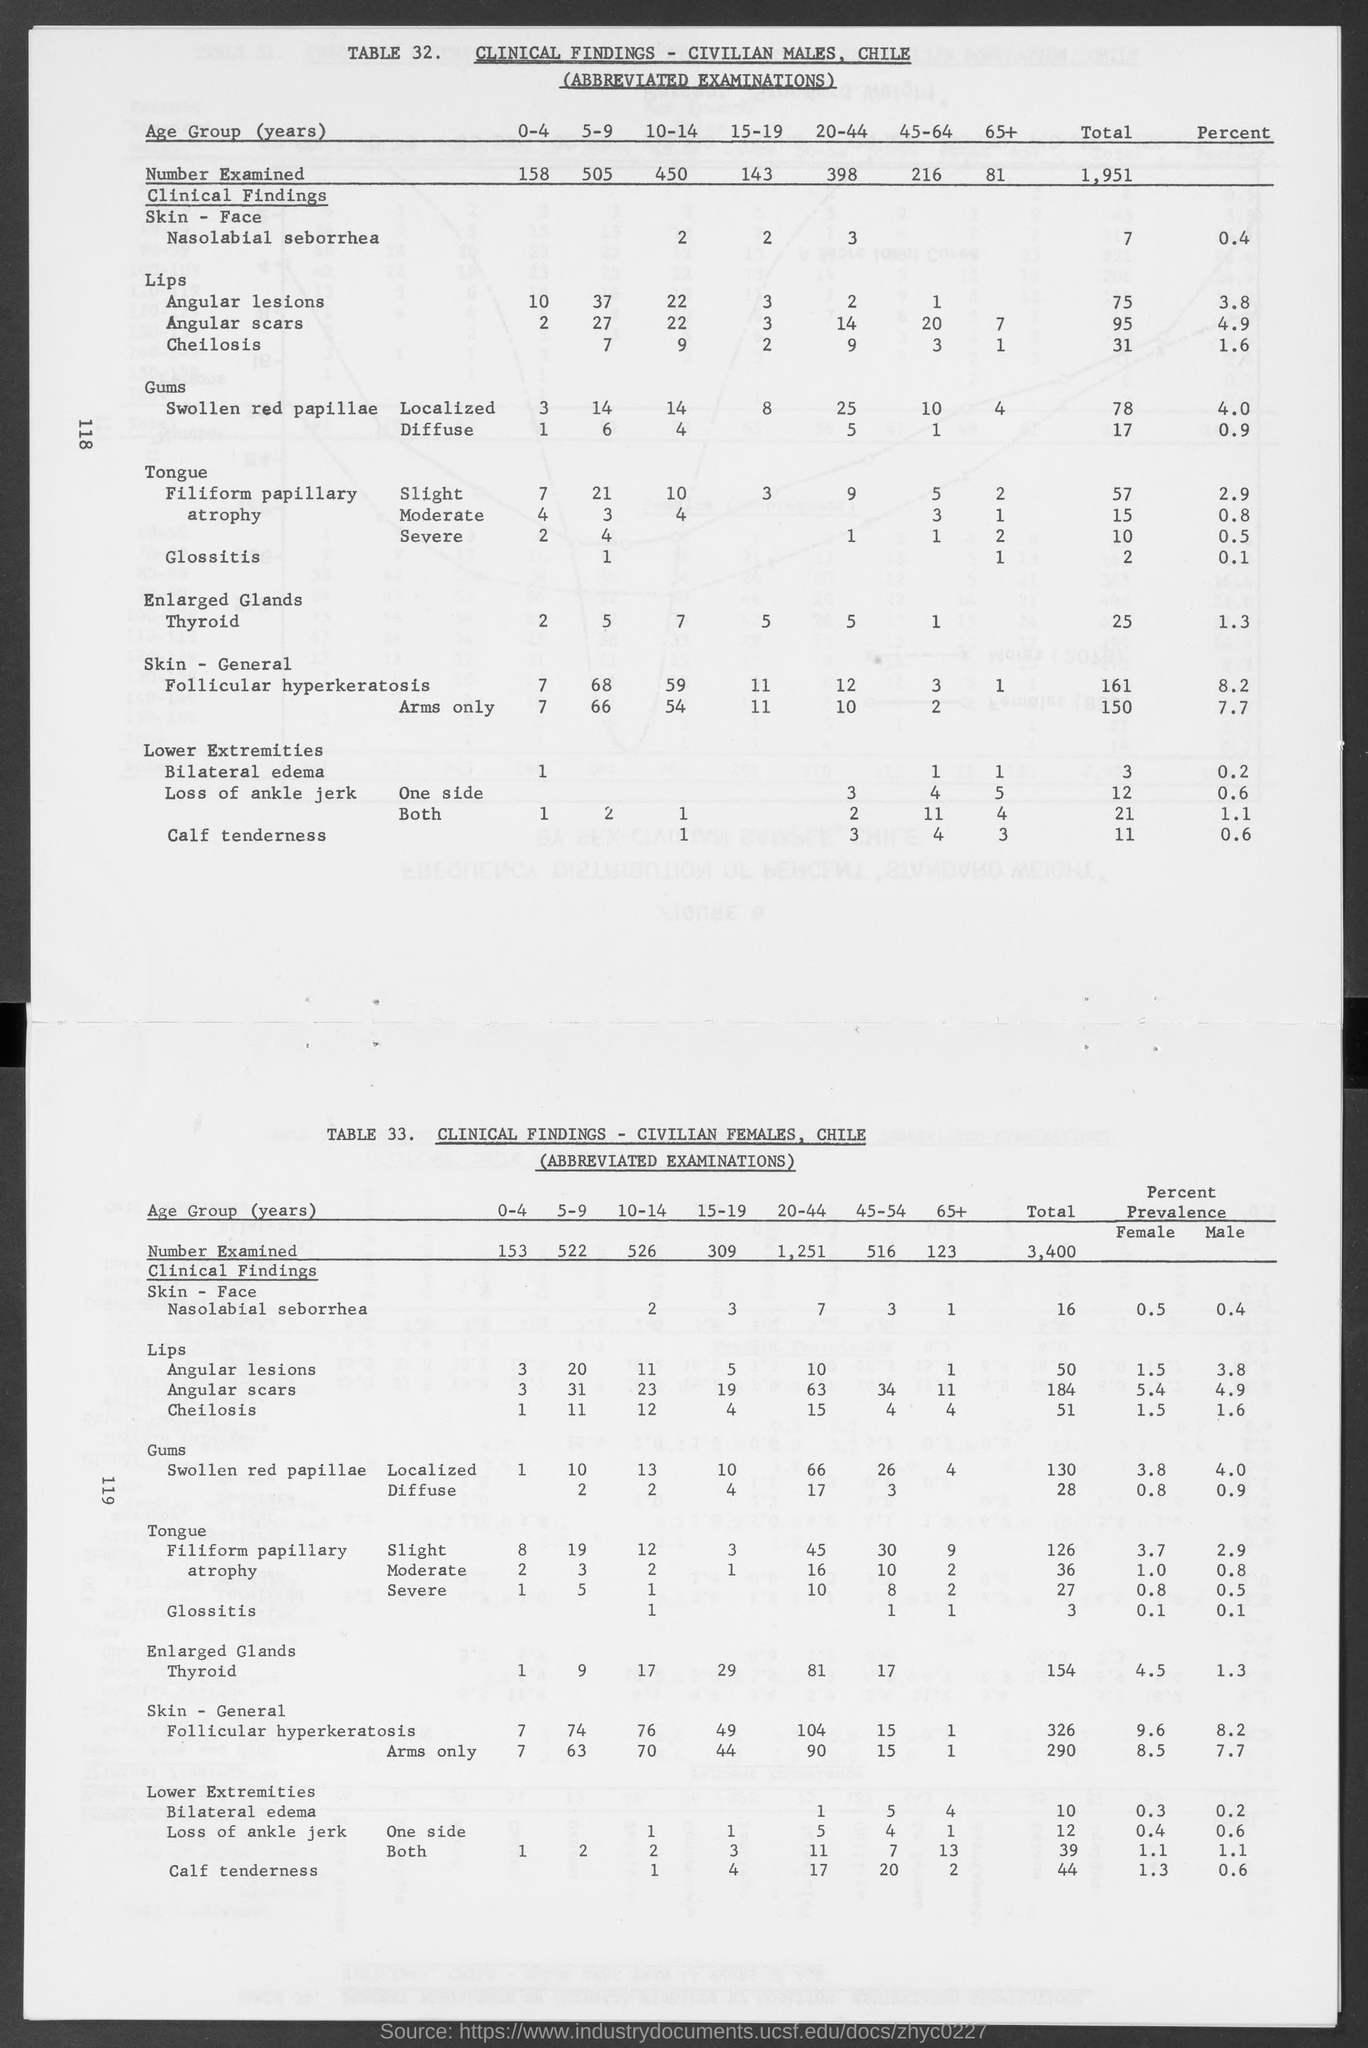What is the Number Examined for Civilian Males, Chile for Age group 0-4 Years?
Provide a short and direct response. 158. What is the Number Examined for Civilian Males, Chile for Age group 5-9 Years?
Ensure brevity in your answer.  505. What is the Number Examined for Civilian Males, Chile for Age group 10-14 Years?
Your answer should be compact. 450. What is the Number Examined for Civilian Males, Chile for Age group 15-19 Years?
Provide a succinct answer. 143. What is the Number Examined for Civilian Males, Chile for Age group 20-44 Years?
Offer a terse response. 398. What is the Number Examined for Civilian Males, Chile for Age group 45-64 Years?
Keep it short and to the point. 216. What is the Number Examined for Civilian Males, Chile for Age group 65+ Years?
Offer a very short reply. 81. What is the Total Number Examined for Civilian Males, Chile?
Keep it short and to the point. 1,951. What is the Number Examined for Civilian FeMales, Chile for Age group 10-14 Years?
Give a very brief answer. 526. What is the Number Examined for Civilian FeMales, Chile for Age group 0-4 Years?
Ensure brevity in your answer.  153. 